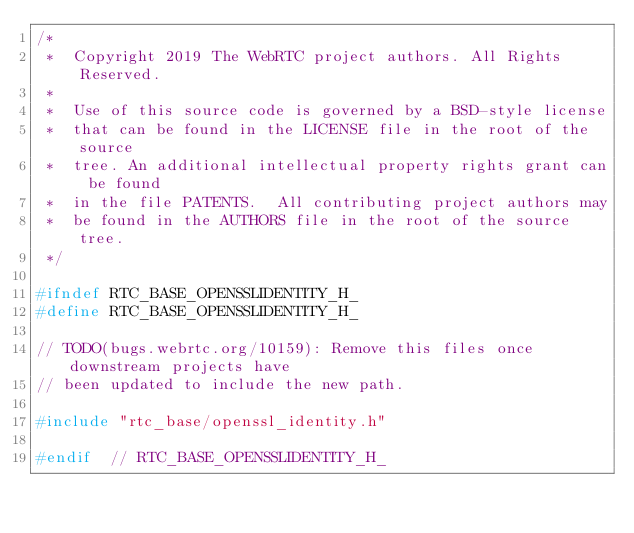<code> <loc_0><loc_0><loc_500><loc_500><_C_>/*
 *  Copyright 2019 The WebRTC project authors. All Rights Reserved.
 *
 *  Use of this source code is governed by a BSD-style license
 *  that can be found in the LICENSE file in the root of the source
 *  tree. An additional intellectual property rights grant can be found
 *  in the file PATENTS.  All contributing project authors may
 *  be found in the AUTHORS file in the root of the source tree.
 */

#ifndef RTC_BASE_OPENSSLIDENTITY_H_
#define RTC_BASE_OPENSSLIDENTITY_H_

// TODO(bugs.webrtc.org/10159): Remove this files once downstream projects have
// been updated to include the new path.

#include "rtc_base/openssl_identity.h"

#endif  // RTC_BASE_OPENSSLIDENTITY_H_
</code> 